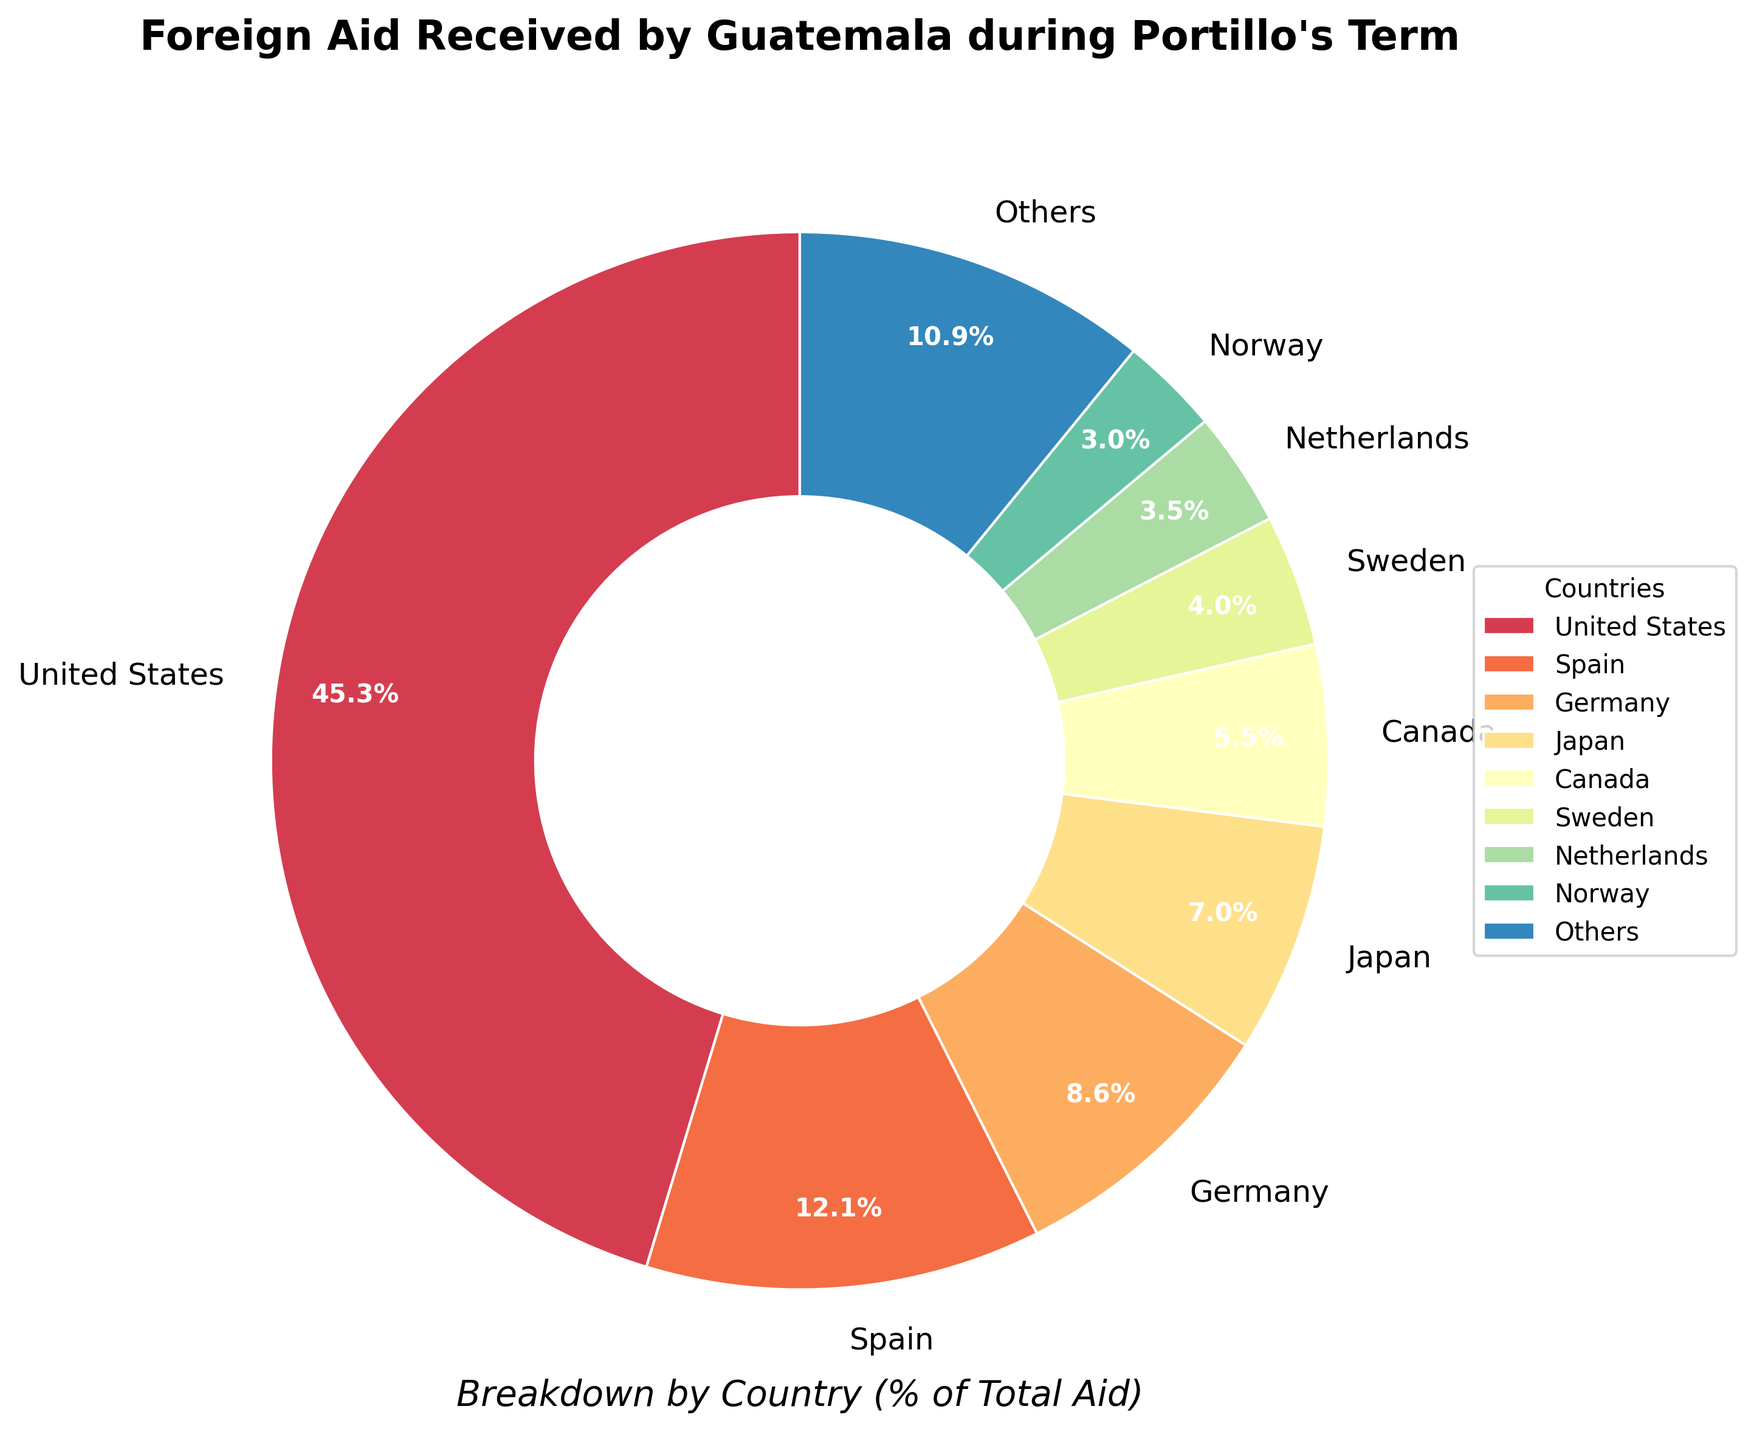What percentage of the total aid does the United States contribute? From the pie chart, the United States' segment is labeled with the percentage of the total aid it contributes.
Answer: 47.3% Which country provides less aid: Germany or Japan? By comparing the percentages labeled on the pie chart for Germany and Japan, Japan provides slightly less aid than Germany. Germany is labeled with 8.9%, while Japan is labeled with 7.4%.
Answer: Japan What is the combined percentage of aid from Norway and Denmark? From the pie chart, locate the segments labeled for Norway and Denmark. Note the percentages: Norway (3.2%) and Denmark (2.1%). Add these percentages together: 3.2% + 2.1%.
Answer: 5.3% Among the top eight donor countries, what is the visual relationship between the largest and smallest segment? Visually inspect the pie chart and identify the largest and smallest segments among the top eight donors. The United States has the largest segment, while Norway has the smallest among the top eight.
Answer: The largest segment (United States) is significantly larger than the smallest segment (Norway) How does the contribution from Canada compare to that of Spain? Examine the pie chart to compare the sizes of the segments for Canada and Spain, as well as the labeled percentages. Spain contributes more aid (12.6%) compared to Canada (5.8%).
Answer: Spain contributes more What is the percentage difference between the aid amounts from the top two contributors? Identify the top two contributors from the pie chart: the United States and Spain. The percentages are 47.3% (USA) and 12.6% (Spain). Subtract the smaller percentage from the larger one: 47.3% - 12.6%.
Answer: 34.7% What color is used to represent the aid from Sweden? Look at the pie chart and find the segment labeled with Sweden. Note the color used for this segment.
Answer: Check the specific visual color representing Sweden What proportion of the total aid is provided by countries categorized as ‘Others’? Locate the ‘Others’ segment on the pie chart and note its percentage of the total aid.
Answer: 14.9% Compare the aid amounts from Switzerland and the Netherlands. Which is higher and by how much? Find the segments for Switzerland and the Netherlands in the pie chart. Compare their percentages: Netherlands (3.7%) and Switzerland (2.6%). Subtract the smaller percentage from the larger: 3.7% - 2.6%.
Answer: Netherlands by 1.1% Identify the country with the third-highest contribution. Examine the segments in the pie chart in descending order of their sizes. The third-highest is Germany, following the United States and Spain.
Answer: Germany 